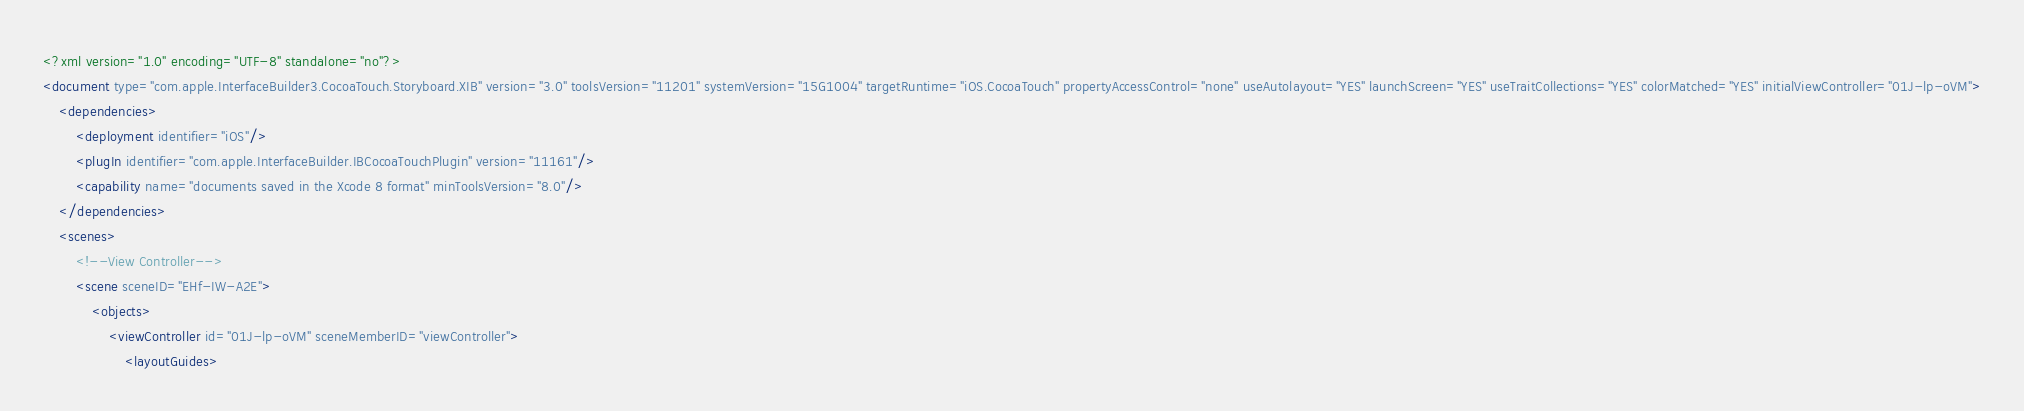<code> <loc_0><loc_0><loc_500><loc_500><_XML_><?xml version="1.0" encoding="UTF-8" standalone="no"?>
<document type="com.apple.InterfaceBuilder3.CocoaTouch.Storyboard.XIB" version="3.0" toolsVersion="11201" systemVersion="15G1004" targetRuntime="iOS.CocoaTouch" propertyAccessControl="none" useAutolayout="YES" launchScreen="YES" useTraitCollections="YES" colorMatched="YES" initialViewController="01J-lp-oVM">
    <dependencies>
        <deployment identifier="iOS"/>
        <plugIn identifier="com.apple.InterfaceBuilder.IBCocoaTouchPlugin" version="11161"/>
        <capability name="documents saved in the Xcode 8 format" minToolsVersion="8.0"/>
    </dependencies>
    <scenes>
        <!--View Controller-->
        <scene sceneID="EHf-IW-A2E">
            <objects>
                <viewController id="01J-lp-oVM" sceneMemberID="viewController">
                    <layoutGuides></code> 